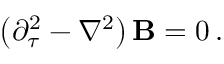<formula> <loc_0><loc_0><loc_500><loc_500>\left ( \partial _ { \tau } ^ { 2 } - \nabla ^ { 2 } \right ) { B } = 0 \, .</formula> 